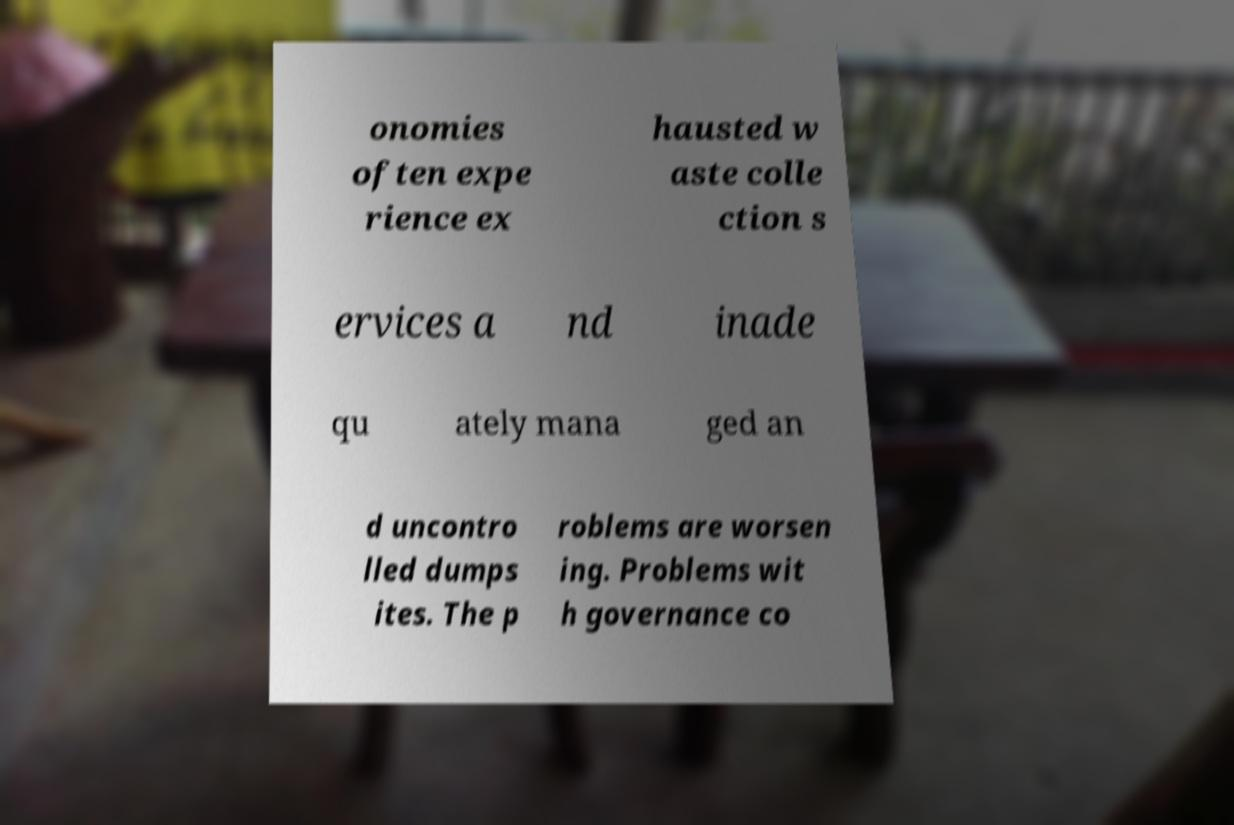Please identify and transcribe the text found in this image. onomies often expe rience ex hausted w aste colle ction s ervices a nd inade qu ately mana ged an d uncontro lled dumps ites. The p roblems are worsen ing. Problems wit h governance co 